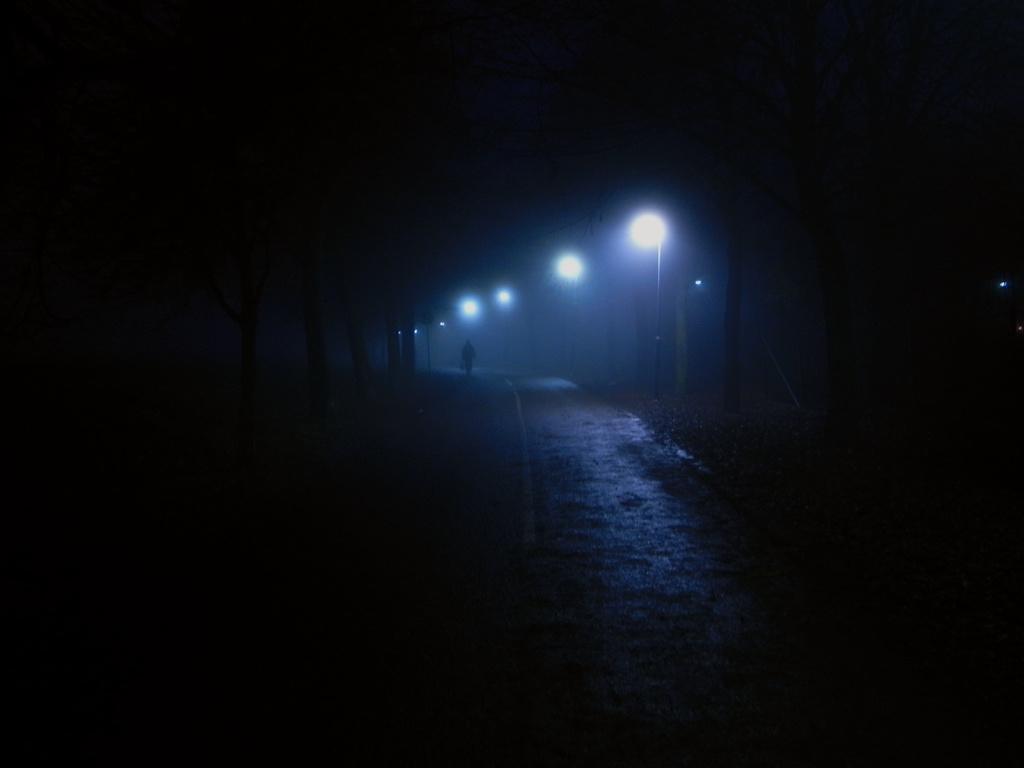Describe this image in one or two sentences. It is a dark image. In this image, we can see a person, walkway, street lights, pole, board and trees. 